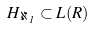Convert formula to latex. <formula><loc_0><loc_0><loc_500><loc_500>H _ { \aleph _ { 1 } } \subset L ( R )</formula> 